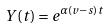<formula> <loc_0><loc_0><loc_500><loc_500>Y ( t ) = e ^ { \alpha ( v - s ) t }</formula> 